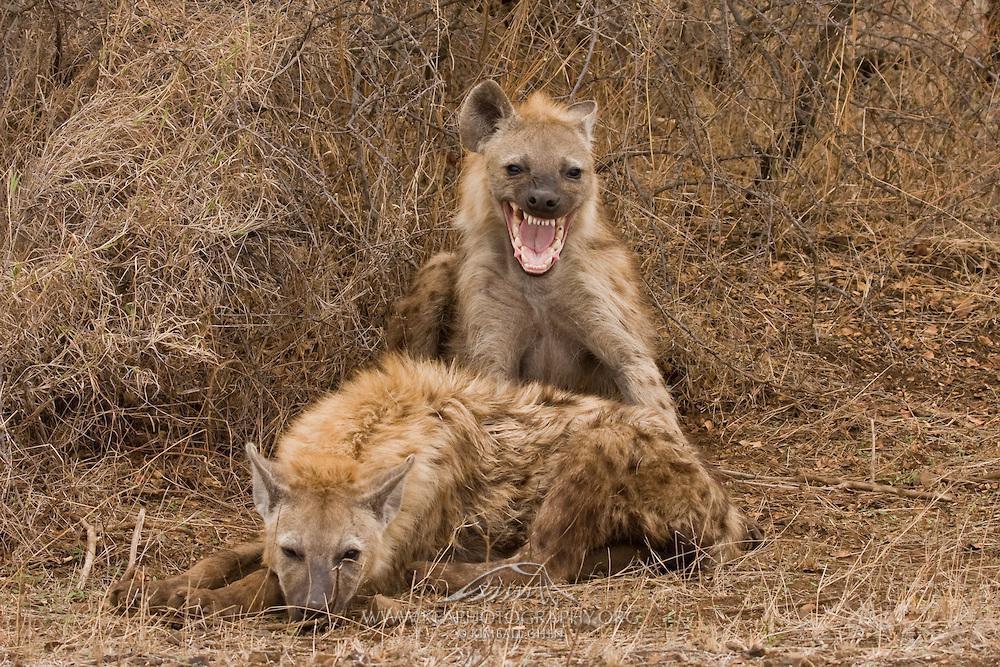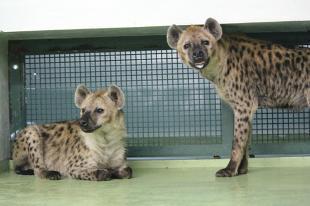The first image is the image on the left, the second image is the image on the right. Analyze the images presented: Is the assertion "One animal is lying down and another is standing in at least one of the images." valid? Answer yes or no. Yes. The first image is the image on the left, the second image is the image on the right. Examine the images to the left and right. Is the description "An image shows two hyenas posed nose to nose, with no carcass between them." accurate? Answer yes or no. No. 